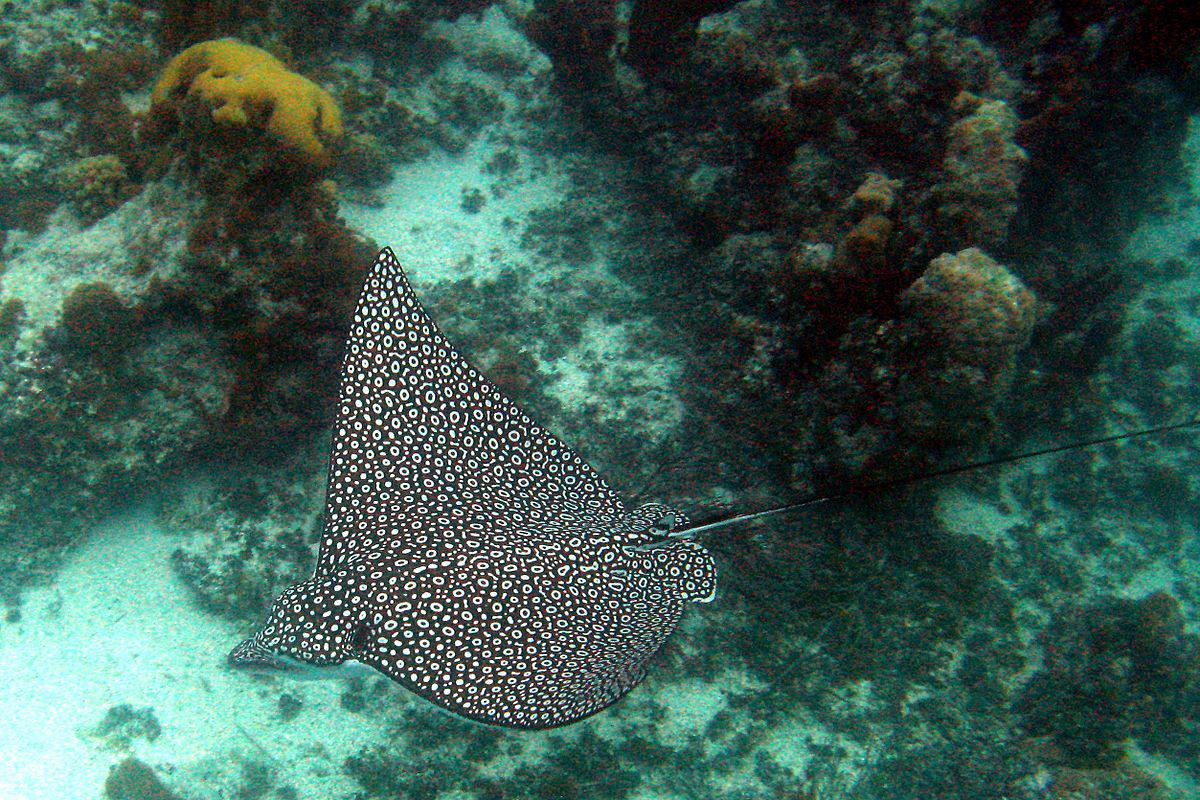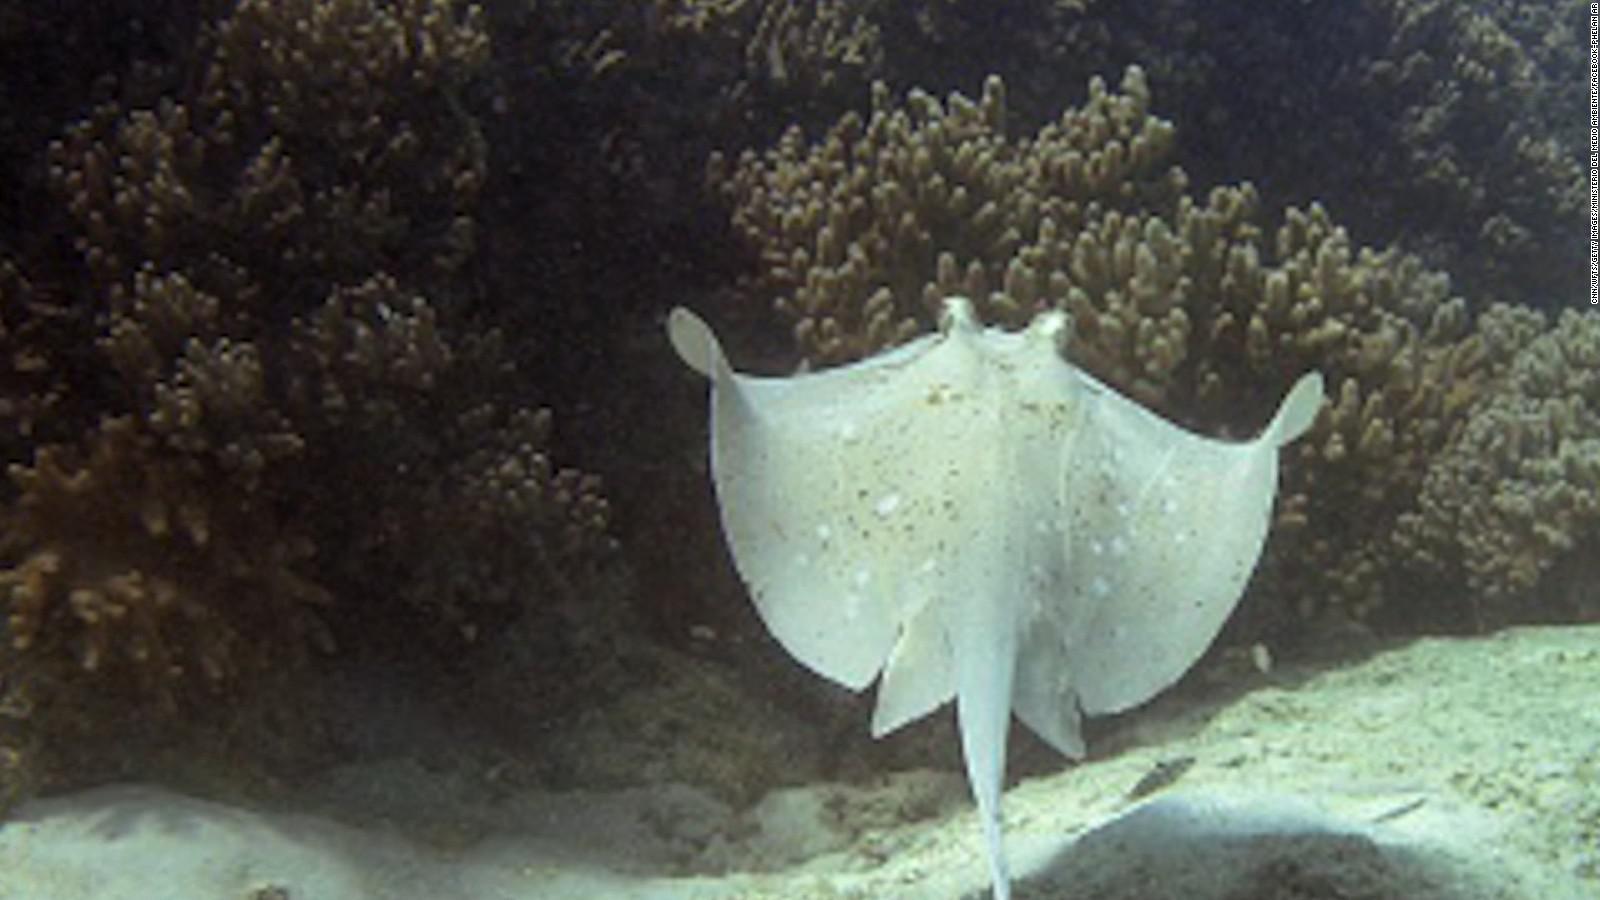The first image is the image on the left, the second image is the image on the right. For the images displayed, is the sentence "Right image shows one pale, almost white stingray." factually correct? Answer yes or no. Yes. 